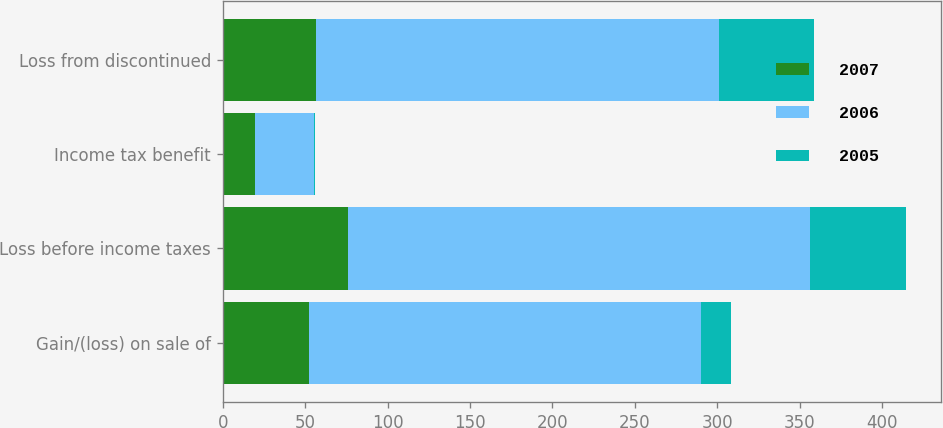<chart> <loc_0><loc_0><loc_500><loc_500><stacked_bar_chart><ecel><fcel>Gain/(loss) on sale of<fcel>Loss before income taxes<fcel>Income tax benefit<fcel>Loss from discontinued<nl><fcel>2007<fcel>52.5<fcel>75.8<fcel>19.4<fcel>56.4<nl><fcel>2006<fcel>237.4<fcel>280.6<fcel>36<fcel>244.6<nl><fcel>2005<fcel>18.7<fcel>58.4<fcel>0.8<fcel>57.6<nl></chart> 